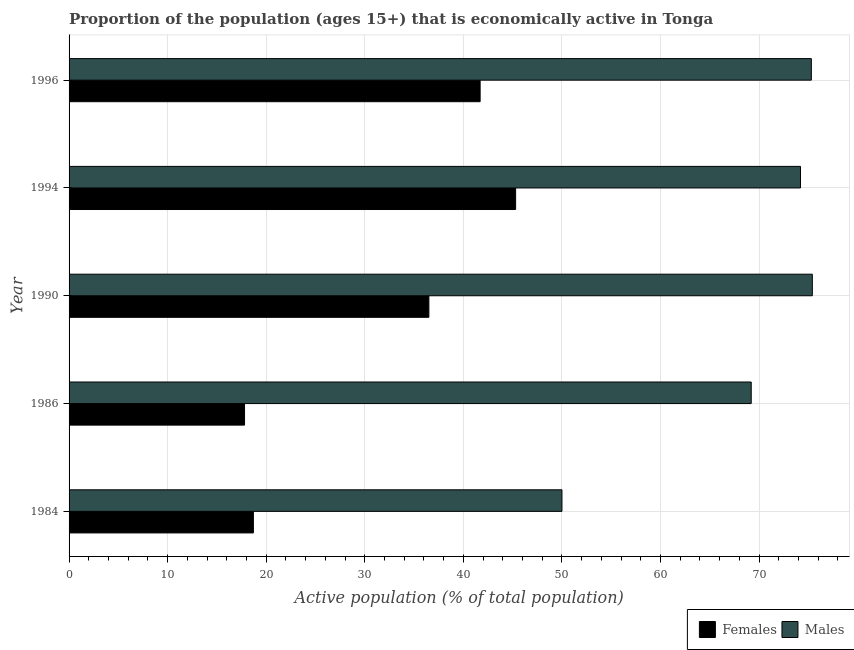How many different coloured bars are there?
Ensure brevity in your answer.  2. How many groups of bars are there?
Provide a short and direct response. 5. How many bars are there on the 2nd tick from the bottom?
Offer a terse response. 2. In how many cases, is the number of bars for a given year not equal to the number of legend labels?
Your response must be concise. 0. What is the percentage of economically active male population in 1984?
Your answer should be compact. 50. Across all years, what is the maximum percentage of economically active female population?
Provide a short and direct response. 45.3. Across all years, what is the minimum percentage of economically active female population?
Make the answer very short. 17.8. In which year was the percentage of economically active female population maximum?
Make the answer very short. 1994. In which year was the percentage of economically active female population minimum?
Ensure brevity in your answer.  1986. What is the total percentage of economically active male population in the graph?
Your response must be concise. 344.1. What is the difference between the percentage of economically active female population in 1984 and that in 1990?
Keep it short and to the point. -17.8. What is the difference between the percentage of economically active male population in 1990 and the percentage of economically active female population in 1994?
Provide a succinct answer. 30.1. What is the average percentage of economically active male population per year?
Ensure brevity in your answer.  68.82. In the year 1994, what is the difference between the percentage of economically active female population and percentage of economically active male population?
Offer a terse response. -28.9. In how many years, is the percentage of economically active female population greater than 60 %?
Offer a terse response. 0. What is the ratio of the percentage of economically active female population in 1986 to that in 1990?
Ensure brevity in your answer.  0.49. Is the difference between the percentage of economically active male population in 1984 and 1986 greater than the difference between the percentage of economically active female population in 1984 and 1986?
Your answer should be compact. No. What is the difference between the highest and the second highest percentage of economically active female population?
Provide a succinct answer. 3.6. What is the difference between the highest and the lowest percentage of economically active male population?
Keep it short and to the point. 25.4. Is the sum of the percentage of economically active male population in 1986 and 1994 greater than the maximum percentage of economically active female population across all years?
Your answer should be very brief. Yes. What does the 1st bar from the top in 1984 represents?
Your answer should be very brief. Males. What does the 2nd bar from the bottom in 1984 represents?
Your answer should be compact. Males. How many bars are there?
Your answer should be very brief. 10. How many years are there in the graph?
Offer a terse response. 5. What is the title of the graph?
Offer a very short reply. Proportion of the population (ages 15+) that is economically active in Tonga. What is the label or title of the X-axis?
Offer a very short reply. Active population (% of total population). What is the label or title of the Y-axis?
Ensure brevity in your answer.  Year. What is the Active population (% of total population) of Females in 1984?
Your answer should be very brief. 18.7. What is the Active population (% of total population) in Females in 1986?
Your answer should be very brief. 17.8. What is the Active population (% of total population) in Males in 1986?
Make the answer very short. 69.2. What is the Active population (% of total population) of Females in 1990?
Keep it short and to the point. 36.5. What is the Active population (% of total population) in Males in 1990?
Ensure brevity in your answer.  75.4. What is the Active population (% of total population) in Females in 1994?
Make the answer very short. 45.3. What is the Active population (% of total population) of Males in 1994?
Keep it short and to the point. 74.2. What is the Active population (% of total population) in Females in 1996?
Offer a terse response. 41.7. What is the Active population (% of total population) of Males in 1996?
Give a very brief answer. 75.3. Across all years, what is the maximum Active population (% of total population) in Females?
Keep it short and to the point. 45.3. Across all years, what is the maximum Active population (% of total population) in Males?
Give a very brief answer. 75.4. Across all years, what is the minimum Active population (% of total population) in Females?
Ensure brevity in your answer.  17.8. Across all years, what is the minimum Active population (% of total population) in Males?
Provide a short and direct response. 50. What is the total Active population (% of total population) in Females in the graph?
Provide a succinct answer. 160. What is the total Active population (% of total population) of Males in the graph?
Offer a very short reply. 344.1. What is the difference between the Active population (% of total population) in Males in 1984 and that in 1986?
Provide a succinct answer. -19.2. What is the difference between the Active population (% of total population) in Females in 1984 and that in 1990?
Make the answer very short. -17.8. What is the difference between the Active population (% of total population) in Males in 1984 and that in 1990?
Give a very brief answer. -25.4. What is the difference between the Active population (% of total population) of Females in 1984 and that in 1994?
Offer a very short reply. -26.6. What is the difference between the Active population (% of total population) in Males in 1984 and that in 1994?
Provide a short and direct response. -24.2. What is the difference between the Active population (% of total population) in Males in 1984 and that in 1996?
Your answer should be very brief. -25.3. What is the difference between the Active population (% of total population) in Females in 1986 and that in 1990?
Offer a terse response. -18.7. What is the difference between the Active population (% of total population) of Males in 1986 and that in 1990?
Ensure brevity in your answer.  -6.2. What is the difference between the Active population (% of total population) in Females in 1986 and that in 1994?
Offer a very short reply. -27.5. What is the difference between the Active population (% of total population) of Males in 1986 and that in 1994?
Provide a succinct answer. -5. What is the difference between the Active population (% of total population) of Females in 1986 and that in 1996?
Offer a terse response. -23.9. What is the difference between the Active population (% of total population) in Males in 1990 and that in 1994?
Ensure brevity in your answer.  1.2. What is the difference between the Active population (% of total population) in Females in 1994 and that in 1996?
Keep it short and to the point. 3.6. What is the difference between the Active population (% of total population) of Females in 1984 and the Active population (% of total population) of Males in 1986?
Keep it short and to the point. -50.5. What is the difference between the Active population (% of total population) of Females in 1984 and the Active population (% of total population) of Males in 1990?
Your answer should be compact. -56.7. What is the difference between the Active population (% of total population) of Females in 1984 and the Active population (% of total population) of Males in 1994?
Make the answer very short. -55.5. What is the difference between the Active population (% of total population) in Females in 1984 and the Active population (% of total population) in Males in 1996?
Provide a succinct answer. -56.6. What is the difference between the Active population (% of total population) of Females in 1986 and the Active population (% of total population) of Males in 1990?
Provide a short and direct response. -57.6. What is the difference between the Active population (% of total population) of Females in 1986 and the Active population (% of total population) of Males in 1994?
Your answer should be very brief. -56.4. What is the difference between the Active population (% of total population) of Females in 1986 and the Active population (% of total population) of Males in 1996?
Ensure brevity in your answer.  -57.5. What is the difference between the Active population (% of total population) of Females in 1990 and the Active population (% of total population) of Males in 1994?
Provide a short and direct response. -37.7. What is the difference between the Active population (% of total population) of Females in 1990 and the Active population (% of total population) of Males in 1996?
Offer a very short reply. -38.8. What is the difference between the Active population (% of total population) in Females in 1994 and the Active population (% of total population) in Males in 1996?
Ensure brevity in your answer.  -30. What is the average Active population (% of total population) in Females per year?
Offer a terse response. 32. What is the average Active population (% of total population) of Males per year?
Your answer should be compact. 68.82. In the year 1984, what is the difference between the Active population (% of total population) of Females and Active population (% of total population) of Males?
Your answer should be very brief. -31.3. In the year 1986, what is the difference between the Active population (% of total population) in Females and Active population (% of total population) in Males?
Your answer should be very brief. -51.4. In the year 1990, what is the difference between the Active population (% of total population) of Females and Active population (% of total population) of Males?
Your response must be concise. -38.9. In the year 1994, what is the difference between the Active population (% of total population) of Females and Active population (% of total population) of Males?
Offer a terse response. -28.9. In the year 1996, what is the difference between the Active population (% of total population) of Females and Active population (% of total population) of Males?
Make the answer very short. -33.6. What is the ratio of the Active population (% of total population) of Females in 1984 to that in 1986?
Your answer should be very brief. 1.05. What is the ratio of the Active population (% of total population) of Males in 1984 to that in 1986?
Your answer should be very brief. 0.72. What is the ratio of the Active population (% of total population) in Females in 1984 to that in 1990?
Provide a short and direct response. 0.51. What is the ratio of the Active population (% of total population) of Males in 1984 to that in 1990?
Offer a terse response. 0.66. What is the ratio of the Active population (% of total population) of Females in 1984 to that in 1994?
Keep it short and to the point. 0.41. What is the ratio of the Active population (% of total population) in Males in 1984 to that in 1994?
Make the answer very short. 0.67. What is the ratio of the Active population (% of total population) of Females in 1984 to that in 1996?
Offer a terse response. 0.45. What is the ratio of the Active population (% of total population) of Males in 1984 to that in 1996?
Your answer should be compact. 0.66. What is the ratio of the Active population (% of total population) of Females in 1986 to that in 1990?
Make the answer very short. 0.49. What is the ratio of the Active population (% of total population) of Males in 1986 to that in 1990?
Keep it short and to the point. 0.92. What is the ratio of the Active population (% of total population) of Females in 1986 to that in 1994?
Provide a succinct answer. 0.39. What is the ratio of the Active population (% of total population) in Males in 1986 to that in 1994?
Provide a succinct answer. 0.93. What is the ratio of the Active population (% of total population) of Females in 1986 to that in 1996?
Make the answer very short. 0.43. What is the ratio of the Active population (% of total population) in Males in 1986 to that in 1996?
Ensure brevity in your answer.  0.92. What is the ratio of the Active population (% of total population) in Females in 1990 to that in 1994?
Give a very brief answer. 0.81. What is the ratio of the Active population (% of total population) of Males in 1990 to that in 1994?
Provide a short and direct response. 1.02. What is the ratio of the Active population (% of total population) in Females in 1990 to that in 1996?
Offer a very short reply. 0.88. What is the ratio of the Active population (% of total population) of Females in 1994 to that in 1996?
Your response must be concise. 1.09. What is the ratio of the Active population (% of total population) in Males in 1994 to that in 1996?
Your response must be concise. 0.99. What is the difference between the highest and the second highest Active population (% of total population) in Females?
Your answer should be compact. 3.6. What is the difference between the highest and the second highest Active population (% of total population) of Males?
Provide a succinct answer. 0.1. What is the difference between the highest and the lowest Active population (% of total population) in Females?
Ensure brevity in your answer.  27.5. What is the difference between the highest and the lowest Active population (% of total population) in Males?
Your answer should be very brief. 25.4. 